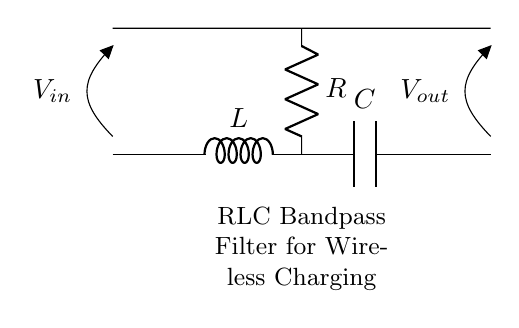What components are present in this circuit? The diagram shows three main components: a resistor, an inductor, and a capacitor. These components are labeled as R, L, and C, respectively.
Answer: Resistor, Inductor, Capacitor What is the function of the inductor in this RLC filter? The inductor stores energy in its magnetic field and introduces a lagging current, which helps determine the filter's frequency response. It plays a crucial role in shaping the bandwidth and resonance of the circuit.
Answer: Energy storage, frequency shaping What type of filter is represented by this circuit? The combination of a resistor, inductor, and capacitor in this configuration allows specific frequency ranges to pass while attenuating others, identifying it as a bandpass filter.
Answer: Bandpass filter What is the voltage source labeled in the diagram? The voltage source is indicated as V in with an arrow suggesting its direction into the circuit. This source provides the necessary input voltage for the filter's operation.
Answer: V in What occurs at the output of the circuit? The output voltage, denoted as V out, represents the filtered signal that is obtained after the input has passed through the RLC configuration and has undergone selection for the desired frequency.
Answer: V out What effect does the resistor have on the filter's characteristics? The resistor introduces damping in the circuit, which can reduce the quality factor (Q) of the bandpass filter, thus affecting its bandwidth and peak gain. This affects how sharp or broad the response of the filter is to frequencies.
Answer: Damping, affects bandwidth What is the relationship between the components' values in determining the filter's center frequency? The center frequency (f0) of the bandpass filter is determined by the values of L and C, calculated using the formula f0 = 1/(2π√(LC)), forming a crucial relationship for tuning the filter to the desired operating frequency.
Answer: f0 = 1/(2π√(LC)) 